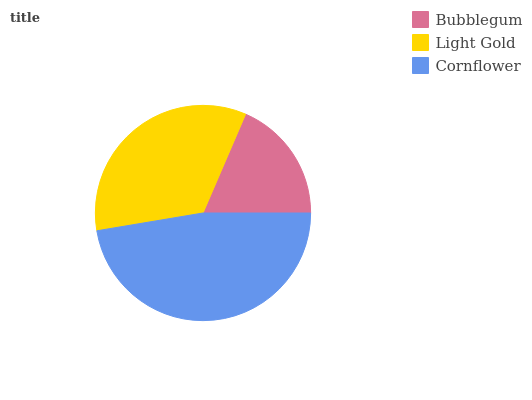Is Bubblegum the minimum?
Answer yes or no. Yes. Is Cornflower the maximum?
Answer yes or no. Yes. Is Light Gold the minimum?
Answer yes or no. No. Is Light Gold the maximum?
Answer yes or no. No. Is Light Gold greater than Bubblegum?
Answer yes or no. Yes. Is Bubblegum less than Light Gold?
Answer yes or no. Yes. Is Bubblegum greater than Light Gold?
Answer yes or no. No. Is Light Gold less than Bubblegum?
Answer yes or no. No. Is Light Gold the high median?
Answer yes or no. Yes. Is Light Gold the low median?
Answer yes or no. Yes. Is Bubblegum the high median?
Answer yes or no. No. Is Bubblegum the low median?
Answer yes or no. No. 